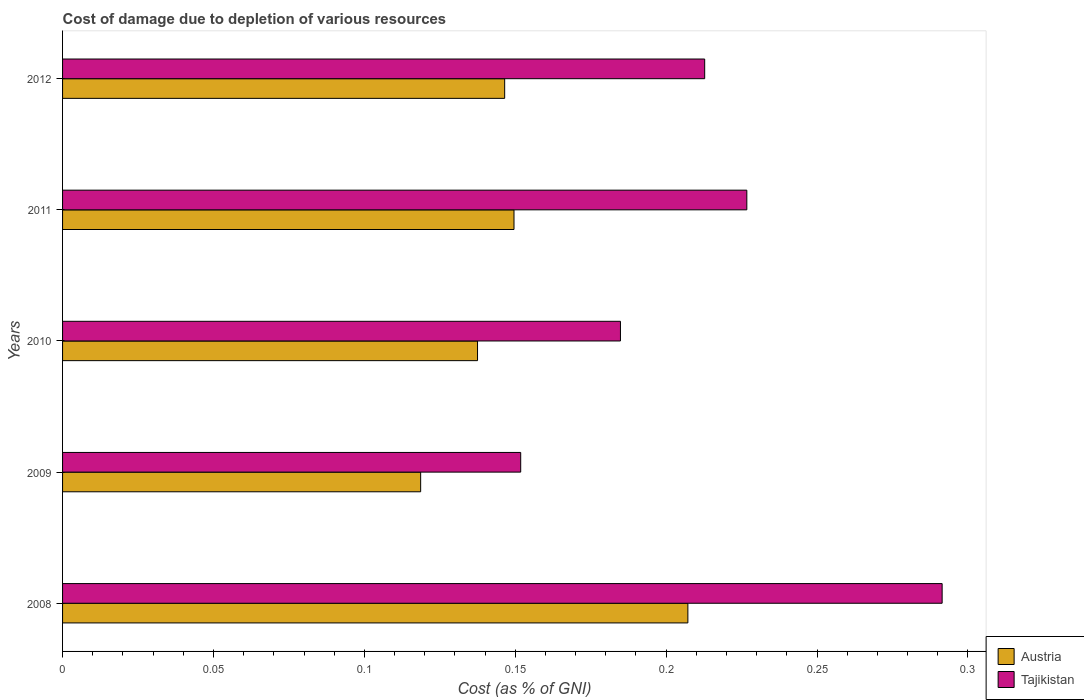How many different coloured bars are there?
Offer a very short reply. 2. How many groups of bars are there?
Keep it short and to the point. 5. What is the cost of damage caused due to the depletion of various resources in Tajikistan in 2009?
Offer a terse response. 0.15. Across all years, what is the maximum cost of damage caused due to the depletion of various resources in Austria?
Keep it short and to the point. 0.21. Across all years, what is the minimum cost of damage caused due to the depletion of various resources in Austria?
Your response must be concise. 0.12. In which year was the cost of damage caused due to the depletion of various resources in Tajikistan maximum?
Give a very brief answer. 2008. What is the total cost of damage caused due to the depletion of various resources in Tajikistan in the graph?
Keep it short and to the point. 1.07. What is the difference between the cost of damage caused due to the depletion of various resources in Tajikistan in 2009 and that in 2010?
Your answer should be compact. -0.03. What is the difference between the cost of damage caused due to the depletion of various resources in Austria in 2011 and the cost of damage caused due to the depletion of various resources in Tajikistan in 2008?
Offer a very short reply. -0.14. What is the average cost of damage caused due to the depletion of various resources in Tajikistan per year?
Provide a short and direct response. 0.21. In the year 2008, what is the difference between the cost of damage caused due to the depletion of various resources in Tajikistan and cost of damage caused due to the depletion of various resources in Austria?
Your answer should be very brief. 0.08. In how many years, is the cost of damage caused due to the depletion of various resources in Tajikistan greater than 0.05 %?
Make the answer very short. 5. What is the ratio of the cost of damage caused due to the depletion of various resources in Austria in 2010 to that in 2011?
Provide a short and direct response. 0.92. Is the difference between the cost of damage caused due to the depletion of various resources in Tajikistan in 2009 and 2010 greater than the difference between the cost of damage caused due to the depletion of various resources in Austria in 2009 and 2010?
Give a very brief answer. No. What is the difference between the highest and the second highest cost of damage caused due to the depletion of various resources in Austria?
Offer a terse response. 0.06. What is the difference between the highest and the lowest cost of damage caused due to the depletion of various resources in Austria?
Ensure brevity in your answer.  0.09. In how many years, is the cost of damage caused due to the depletion of various resources in Tajikistan greater than the average cost of damage caused due to the depletion of various resources in Tajikistan taken over all years?
Provide a short and direct response. 2. What does the 2nd bar from the bottom in 2010 represents?
Offer a terse response. Tajikistan. How many bars are there?
Offer a terse response. 10. Are all the bars in the graph horizontal?
Your answer should be compact. Yes. How many years are there in the graph?
Give a very brief answer. 5. Are the values on the major ticks of X-axis written in scientific E-notation?
Give a very brief answer. No. Does the graph contain any zero values?
Provide a short and direct response. No. Does the graph contain grids?
Provide a short and direct response. No. Where does the legend appear in the graph?
Your response must be concise. Bottom right. How are the legend labels stacked?
Offer a terse response. Vertical. What is the title of the graph?
Your answer should be very brief. Cost of damage due to depletion of various resources. What is the label or title of the X-axis?
Your answer should be very brief. Cost (as % of GNI). What is the label or title of the Y-axis?
Your answer should be compact. Years. What is the Cost (as % of GNI) in Austria in 2008?
Give a very brief answer. 0.21. What is the Cost (as % of GNI) in Tajikistan in 2008?
Your answer should be compact. 0.29. What is the Cost (as % of GNI) of Austria in 2009?
Your answer should be compact. 0.12. What is the Cost (as % of GNI) of Tajikistan in 2009?
Make the answer very short. 0.15. What is the Cost (as % of GNI) in Austria in 2010?
Your answer should be very brief. 0.14. What is the Cost (as % of GNI) of Tajikistan in 2010?
Provide a short and direct response. 0.18. What is the Cost (as % of GNI) in Austria in 2011?
Your response must be concise. 0.15. What is the Cost (as % of GNI) in Tajikistan in 2011?
Make the answer very short. 0.23. What is the Cost (as % of GNI) of Austria in 2012?
Your response must be concise. 0.15. What is the Cost (as % of GNI) in Tajikistan in 2012?
Your response must be concise. 0.21. Across all years, what is the maximum Cost (as % of GNI) of Austria?
Offer a terse response. 0.21. Across all years, what is the maximum Cost (as % of GNI) in Tajikistan?
Provide a short and direct response. 0.29. Across all years, what is the minimum Cost (as % of GNI) of Austria?
Make the answer very short. 0.12. Across all years, what is the minimum Cost (as % of GNI) in Tajikistan?
Make the answer very short. 0.15. What is the total Cost (as % of GNI) of Austria in the graph?
Offer a very short reply. 0.76. What is the total Cost (as % of GNI) in Tajikistan in the graph?
Provide a succinct answer. 1.07. What is the difference between the Cost (as % of GNI) in Austria in 2008 and that in 2009?
Offer a terse response. 0.09. What is the difference between the Cost (as % of GNI) in Tajikistan in 2008 and that in 2009?
Your answer should be compact. 0.14. What is the difference between the Cost (as % of GNI) in Austria in 2008 and that in 2010?
Offer a very short reply. 0.07. What is the difference between the Cost (as % of GNI) of Tajikistan in 2008 and that in 2010?
Give a very brief answer. 0.11. What is the difference between the Cost (as % of GNI) in Austria in 2008 and that in 2011?
Give a very brief answer. 0.06. What is the difference between the Cost (as % of GNI) of Tajikistan in 2008 and that in 2011?
Your answer should be compact. 0.06. What is the difference between the Cost (as % of GNI) of Austria in 2008 and that in 2012?
Offer a terse response. 0.06. What is the difference between the Cost (as % of GNI) of Tajikistan in 2008 and that in 2012?
Ensure brevity in your answer.  0.08. What is the difference between the Cost (as % of GNI) of Austria in 2009 and that in 2010?
Ensure brevity in your answer.  -0.02. What is the difference between the Cost (as % of GNI) of Tajikistan in 2009 and that in 2010?
Provide a succinct answer. -0.03. What is the difference between the Cost (as % of GNI) of Austria in 2009 and that in 2011?
Give a very brief answer. -0.03. What is the difference between the Cost (as % of GNI) of Tajikistan in 2009 and that in 2011?
Offer a terse response. -0.07. What is the difference between the Cost (as % of GNI) of Austria in 2009 and that in 2012?
Keep it short and to the point. -0.03. What is the difference between the Cost (as % of GNI) of Tajikistan in 2009 and that in 2012?
Provide a succinct answer. -0.06. What is the difference between the Cost (as % of GNI) in Austria in 2010 and that in 2011?
Give a very brief answer. -0.01. What is the difference between the Cost (as % of GNI) in Tajikistan in 2010 and that in 2011?
Give a very brief answer. -0.04. What is the difference between the Cost (as % of GNI) of Austria in 2010 and that in 2012?
Keep it short and to the point. -0.01. What is the difference between the Cost (as % of GNI) in Tajikistan in 2010 and that in 2012?
Your answer should be very brief. -0.03. What is the difference between the Cost (as % of GNI) in Austria in 2011 and that in 2012?
Offer a very short reply. 0. What is the difference between the Cost (as % of GNI) of Tajikistan in 2011 and that in 2012?
Provide a short and direct response. 0.01. What is the difference between the Cost (as % of GNI) in Austria in 2008 and the Cost (as % of GNI) in Tajikistan in 2009?
Your answer should be very brief. 0.06. What is the difference between the Cost (as % of GNI) in Austria in 2008 and the Cost (as % of GNI) in Tajikistan in 2010?
Provide a succinct answer. 0.02. What is the difference between the Cost (as % of GNI) of Austria in 2008 and the Cost (as % of GNI) of Tajikistan in 2011?
Provide a short and direct response. -0.02. What is the difference between the Cost (as % of GNI) in Austria in 2008 and the Cost (as % of GNI) in Tajikistan in 2012?
Your answer should be very brief. -0.01. What is the difference between the Cost (as % of GNI) in Austria in 2009 and the Cost (as % of GNI) in Tajikistan in 2010?
Your answer should be compact. -0.07. What is the difference between the Cost (as % of GNI) of Austria in 2009 and the Cost (as % of GNI) of Tajikistan in 2011?
Your answer should be compact. -0.11. What is the difference between the Cost (as % of GNI) in Austria in 2009 and the Cost (as % of GNI) in Tajikistan in 2012?
Keep it short and to the point. -0.09. What is the difference between the Cost (as % of GNI) of Austria in 2010 and the Cost (as % of GNI) of Tajikistan in 2011?
Provide a succinct answer. -0.09. What is the difference between the Cost (as % of GNI) in Austria in 2010 and the Cost (as % of GNI) in Tajikistan in 2012?
Your response must be concise. -0.08. What is the difference between the Cost (as % of GNI) in Austria in 2011 and the Cost (as % of GNI) in Tajikistan in 2012?
Provide a succinct answer. -0.06. What is the average Cost (as % of GNI) in Austria per year?
Provide a succinct answer. 0.15. What is the average Cost (as % of GNI) of Tajikistan per year?
Your answer should be compact. 0.21. In the year 2008, what is the difference between the Cost (as % of GNI) in Austria and Cost (as % of GNI) in Tajikistan?
Make the answer very short. -0.08. In the year 2009, what is the difference between the Cost (as % of GNI) in Austria and Cost (as % of GNI) in Tajikistan?
Give a very brief answer. -0.03. In the year 2010, what is the difference between the Cost (as % of GNI) in Austria and Cost (as % of GNI) in Tajikistan?
Provide a short and direct response. -0.05. In the year 2011, what is the difference between the Cost (as % of GNI) of Austria and Cost (as % of GNI) of Tajikistan?
Give a very brief answer. -0.08. In the year 2012, what is the difference between the Cost (as % of GNI) of Austria and Cost (as % of GNI) of Tajikistan?
Your answer should be very brief. -0.07. What is the ratio of the Cost (as % of GNI) in Austria in 2008 to that in 2009?
Provide a short and direct response. 1.75. What is the ratio of the Cost (as % of GNI) in Tajikistan in 2008 to that in 2009?
Provide a short and direct response. 1.92. What is the ratio of the Cost (as % of GNI) of Austria in 2008 to that in 2010?
Your answer should be compact. 1.51. What is the ratio of the Cost (as % of GNI) of Tajikistan in 2008 to that in 2010?
Offer a very short reply. 1.58. What is the ratio of the Cost (as % of GNI) in Austria in 2008 to that in 2011?
Your answer should be compact. 1.39. What is the ratio of the Cost (as % of GNI) of Tajikistan in 2008 to that in 2011?
Your response must be concise. 1.29. What is the ratio of the Cost (as % of GNI) of Austria in 2008 to that in 2012?
Provide a succinct answer. 1.41. What is the ratio of the Cost (as % of GNI) in Tajikistan in 2008 to that in 2012?
Make the answer very short. 1.37. What is the ratio of the Cost (as % of GNI) in Austria in 2009 to that in 2010?
Offer a very short reply. 0.86. What is the ratio of the Cost (as % of GNI) in Tajikistan in 2009 to that in 2010?
Offer a terse response. 0.82. What is the ratio of the Cost (as % of GNI) in Austria in 2009 to that in 2011?
Your answer should be very brief. 0.79. What is the ratio of the Cost (as % of GNI) in Tajikistan in 2009 to that in 2011?
Offer a very short reply. 0.67. What is the ratio of the Cost (as % of GNI) in Austria in 2009 to that in 2012?
Offer a terse response. 0.81. What is the ratio of the Cost (as % of GNI) in Tajikistan in 2009 to that in 2012?
Keep it short and to the point. 0.71. What is the ratio of the Cost (as % of GNI) in Austria in 2010 to that in 2011?
Your response must be concise. 0.92. What is the ratio of the Cost (as % of GNI) of Tajikistan in 2010 to that in 2011?
Offer a terse response. 0.82. What is the ratio of the Cost (as % of GNI) in Austria in 2010 to that in 2012?
Your answer should be compact. 0.94. What is the ratio of the Cost (as % of GNI) in Tajikistan in 2010 to that in 2012?
Keep it short and to the point. 0.87. What is the ratio of the Cost (as % of GNI) in Austria in 2011 to that in 2012?
Your response must be concise. 1.02. What is the ratio of the Cost (as % of GNI) in Tajikistan in 2011 to that in 2012?
Give a very brief answer. 1.07. What is the difference between the highest and the second highest Cost (as % of GNI) in Austria?
Provide a succinct answer. 0.06. What is the difference between the highest and the second highest Cost (as % of GNI) of Tajikistan?
Provide a short and direct response. 0.06. What is the difference between the highest and the lowest Cost (as % of GNI) in Austria?
Your answer should be very brief. 0.09. What is the difference between the highest and the lowest Cost (as % of GNI) in Tajikistan?
Make the answer very short. 0.14. 